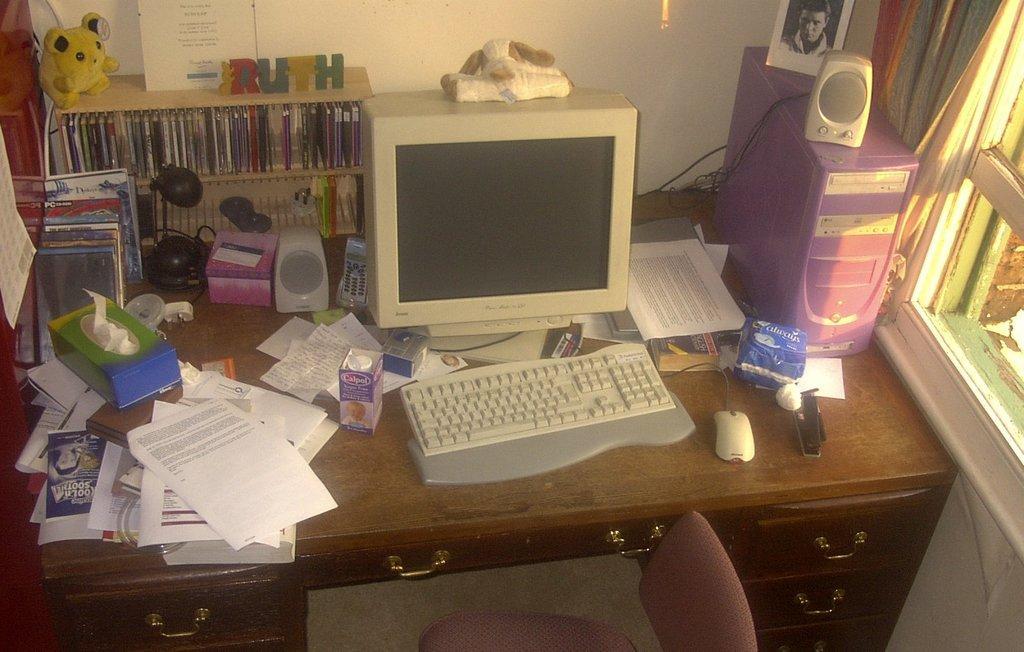Could you give a brief overview of what you see in this image? In the center we can see table,on table we can see monitor,key board,tetra pack,papers,box,mouse,PC,shelf,doll etc. In bottom we can see chair and back we can see wall and window. 